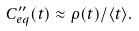Convert formula to latex. <formula><loc_0><loc_0><loc_500><loc_500>C ^ { \prime \prime } _ { e q } ( t ) \approx \rho ( t ) / \langle t \rangle .</formula> 